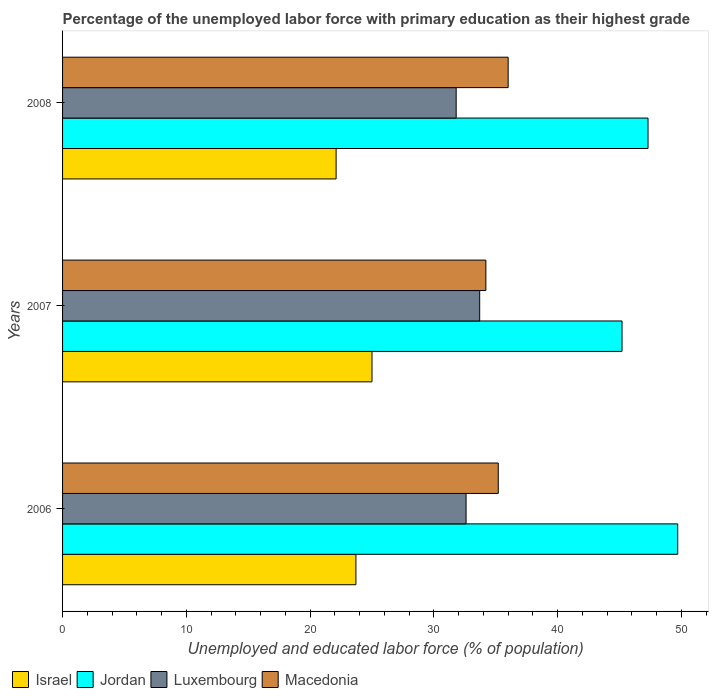How many different coloured bars are there?
Your response must be concise. 4. How many groups of bars are there?
Offer a very short reply. 3. Are the number of bars on each tick of the Y-axis equal?
Provide a short and direct response. Yes. How many bars are there on the 3rd tick from the top?
Provide a succinct answer. 4. How many bars are there on the 2nd tick from the bottom?
Offer a very short reply. 4. What is the label of the 2nd group of bars from the top?
Offer a very short reply. 2007. What is the percentage of the unemployed labor force with primary education in Israel in 2006?
Ensure brevity in your answer.  23.7. Across all years, what is the maximum percentage of the unemployed labor force with primary education in Luxembourg?
Your answer should be compact. 33.7. Across all years, what is the minimum percentage of the unemployed labor force with primary education in Jordan?
Your answer should be very brief. 45.2. In which year was the percentage of the unemployed labor force with primary education in Luxembourg minimum?
Make the answer very short. 2008. What is the total percentage of the unemployed labor force with primary education in Luxembourg in the graph?
Your answer should be compact. 98.1. What is the difference between the percentage of the unemployed labor force with primary education in Israel in 2006 and that in 2007?
Offer a very short reply. -1.3. What is the average percentage of the unemployed labor force with primary education in Luxembourg per year?
Ensure brevity in your answer.  32.7. In the year 2007, what is the difference between the percentage of the unemployed labor force with primary education in Israel and percentage of the unemployed labor force with primary education in Luxembourg?
Provide a succinct answer. -8.7. What is the ratio of the percentage of the unemployed labor force with primary education in Jordan in 2007 to that in 2008?
Your answer should be compact. 0.96. Is the percentage of the unemployed labor force with primary education in Israel in 2007 less than that in 2008?
Offer a terse response. No. What is the difference between the highest and the second highest percentage of the unemployed labor force with primary education in Luxembourg?
Give a very brief answer. 1.1. What is the difference between the highest and the lowest percentage of the unemployed labor force with primary education in Macedonia?
Your response must be concise. 1.8. Is the sum of the percentage of the unemployed labor force with primary education in Macedonia in 2006 and 2008 greater than the maximum percentage of the unemployed labor force with primary education in Israel across all years?
Make the answer very short. Yes. Is it the case that in every year, the sum of the percentage of the unemployed labor force with primary education in Israel and percentage of the unemployed labor force with primary education in Jordan is greater than the sum of percentage of the unemployed labor force with primary education in Macedonia and percentage of the unemployed labor force with primary education in Luxembourg?
Provide a short and direct response. Yes. What does the 4th bar from the bottom in 2006 represents?
Your answer should be compact. Macedonia. Is it the case that in every year, the sum of the percentage of the unemployed labor force with primary education in Luxembourg and percentage of the unemployed labor force with primary education in Macedonia is greater than the percentage of the unemployed labor force with primary education in Israel?
Make the answer very short. Yes. What is the difference between two consecutive major ticks on the X-axis?
Your answer should be compact. 10. Are the values on the major ticks of X-axis written in scientific E-notation?
Keep it short and to the point. No. Does the graph contain any zero values?
Provide a short and direct response. No. How many legend labels are there?
Offer a very short reply. 4. How are the legend labels stacked?
Provide a short and direct response. Horizontal. What is the title of the graph?
Make the answer very short. Percentage of the unemployed labor force with primary education as their highest grade. Does "Gambia, The" appear as one of the legend labels in the graph?
Keep it short and to the point. No. What is the label or title of the X-axis?
Offer a very short reply. Unemployed and educated labor force (% of population). What is the label or title of the Y-axis?
Make the answer very short. Years. What is the Unemployed and educated labor force (% of population) in Israel in 2006?
Make the answer very short. 23.7. What is the Unemployed and educated labor force (% of population) of Jordan in 2006?
Your response must be concise. 49.7. What is the Unemployed and educated labor force (% of population) of Luxembourg in 2006?
Offer a very short reply. 32.6. What is the Unemployed and educated labor force (% of population) in Macedonia in 2006?
Ensure brevity in your answer.  35.2. What is the Unemployed and educated labor force (% of population) of Jordan in 2007?
Make the answer very short. 45.2. What is the Unemployed and educated labor force (% of population) of Luxembourg in 2007?
Offer a very short reply. 33.7. What is the Unemployed and educated labor force (% of population) of Macedonia in 2007?
Keep it short and to the point. 34.2. What is the Unemployed and educated labor force (% of population) in Israel in 2008?
Your answer should be very brief. 22.1. What is the Unemployed and educated labor force (% of population) in Jordan in 2008?
Provide a succinct answer. 47.3. What is the Unemployed and educated labor force (% of population) in Luxembourg in 2008?
Your answer should be compact. 31.8. What is the Unemployed and educated labor force (% of population) in Macedonia in 2008?
Keep it short and to the point. 36. Across all years, what is the maximum Unemployed and educated labor force (% of population) of Israel?
Your answer should be very brief. 25. Across all years, what is the maximum Unemployed and educated labor force (% of population) of Jordan?
Offer a terse response. 49.7. Across all years, what is the maximum Unemployed and educated labor force (% of population) in Luxembourg?
Your response must be concise. 33.7. Across all years, what is the maximum Unemployed and educated labor force (% of population) in Macedonia?
Ensure brevity in your answer.  36. Across all years, what is the minimum Unemployed and educated labor force (% of population) in Israel?
Provide a short and direct response. 22.1. Across all years, what is the minimum Unemployed and educated labor force (% of population) of Jordan?
Give a very brief answer. 45.2. Across all years, what is the minimum Unemployed and educated labor force (% of population) in Luxembourg?
Provide a short and direct response. 31.8. Across all years, what is the minimum Unemployed and educated labor force (% of population) of Macedonia?
Your response must be concise. 34.2. What is the total Unemployed and educated labor force (% of population) in Israel in the graph?
Give a very brief answer. 70.8. What is the total Unemployed and educated labor force (% of population) in Jordan in the graph?
Your answer should be compact. 142.2. What is the total Unemployed and educated labor force (% of population) in Luxembourg in the graph?
Provide a succinct answer. 98.1. What is the total Unemployed and educated labor force (% of population) in Macedonia in the graph?
Your response must be concise. 105.4. What is the difference between the Unemployed and educated labor force (% of population) in Macedonia in 2006 and that in 2007?
Make the answer very short. 1. What is the difference between the Unemployed and educated labor force (% of population) of Jordan in 2006 and that in 2008?
Make the answer very short. 2.4. What is the difference between the Unemployed and educated labor force (% of population) in Luxembourg in 2006 and that in 2008?
Your answer should be very brief. 0.8. What is the difference between the Unemployed and educated labor force (% of population) in Israel in 2007 and that in 2008?
Your answer should be very brief. 2.9. What is the difference between the Unemployed and educated labor force (% of population) of Jordan in 2007 and that in 2008?
Your answer should be very brief. -2.1. What is the difference between the Unemployed and educated labor force (% of population) in Israel in 2006 and the Unemployed and educated labor force (% of population) in Jordan in 2007?
Your response must be concise. -21.5. What is the difference between the Unemployed and educated labor force (% of population) in Israel in 2006 and the Unemployed and educated labor force (% of population) in Luxembourg in 2007?
Provide a short and direct response. -10. What is the difference between the Unemployed and educated labor force (% of population) in Israel in 2006 and the Unemployed and educated labor force (% of population) in Macedonia in 2007?
Make the answer very short. -10.5. What is the difference between the Unemployed and educated labor force (% of population) in Jordan in 2006 and the Unemployed and educated labor force (% of population) in Luxembourg in 2007?
Make the answer very short. 16. What is the difference between the Unemployed and educated labor force (% of population) of Israel in 2006 and the Unemployed and educated labor force (% of population) of Jordan in 2008?
Offer a very short reply. -23.6. What is the difference between the Unemployed and educated labor force (% of population) of Jordan in 2006 and the Unemployed and educated labor force (% of population) of Macedonia in 2008?
Keep it short and to the point. 13.7. What is the difference between the Unemployed and educated labor force (% of population) in Israel in 2007 and the Unemployed and educated labor force (% of population) in Jordan in 2008?
Make the answer very short. -22.3. What is the difference between the Unemployed and educated labor force (% of population) in Israel in 2007 and the Unemployed and educated labor force (% of population) in Luxembourg in 2008?
Your answer should be compact. -6.8. What is the difference between the Unemployed and educated labor force (% of population) in Jordan in 2007 and the Unemployed and educated labor force (% of population) in Luxembourg in 2008?
Your answer should be compact. 13.4. What is the difference between the Unemployed and educated labor force (% of population) in Luxembourg in 2007 and the Unemployed and educated labor force (% of population) in Macedonia in 2008?
Your answer should be compact. -2.3. What is the average Unemployed and educated labor force (% of population) of Israel per year?
Your answer should be compact. 23.6. What is the average Unemployed and educated labor force (% of population) of Jordan per year?
Your answer should be compact. 47.4. What is the average Unemployed and educated labor force (% of population) of Luxembourg per year?
Make the answer very short. 32.7. What is the average Unemployed and educated labor force (% of population) of Macedonia per year?
Your answer should be compact. 35.13. In the year 2006, what is the difference between the Unemployed and educated labor force (% of population) in Jordan and Unemployed and educated labor force (% of population) in Luxembourg?
Your answer should be compact. 17.1. In the year 2006, what is the difference between the Unemployed and educated labor force (% of population) in Luxembourg and Unemployed and educated labor force (% of population) in Macedonia?
Provide a short and direct response. -2.6. In the year 2007, what is the difference between the Unemployed and educated labor force (% of population) of Israel and Unemployed and educated labor force (% of population) of Jordan?
Your answer should be compact. -20.2. In the year 2007, what is the difference between the Unemployed and educated labor force (% of population) in Jordan and Unemployed and educated labor force (% of population) in Luxembourg?
Your answer should be compact. 11.5. In the year 2007, what is the difference between the Unemployed and educated labor force (% of population) of Jordan and Unemployed and educated labor force (% of population) of Macedonia?
Your response must be concise. 11. In the year 2008, what is the difference between the Unemployed and educated labor force (% of population) of Israel and Unemployed and educated labor force (% of population) of Jordan?
Give a very brief answer. -25.2. In the year 2008, what is the difference between the Unemployed and educated labor force (% of population) of Israel and Unemployed and educated labor force (% of population) of Macedonia?
Keep it short and to the point. -13.9. In the year 2008, what is the difference between the Unemployed and educated labor force (% of population) in Jordan and Unemployed and educated labor force (% of population) in Luxembourg?
Offer a terse response. 15.5. In the year 2008, what is the difference between the Unemployed and educated labor force (% of population) of Jordan and Unemployed and educated labor force (% of population) of Macedonia?
Your response must be concise. 11.3. In the year 2008, what is the difference between the Unemployed and educated labor force (% of population) in Luxembourg and Unemployed and educated labor force (% of population) in Macedonia?
Your answer should be compact. -4.2. What is the ratio of the Unemployed and educated labor force (% of population) in Israel in 2006 to that in 2007?
Ensure brevity in your answer.  0.95. What is the ratio of the Unemployed and educated labor force (% of population) in Jordan in 2006 to that in 2007?
Your response must be concise. 1.1. What is the ratio of the Unemployed and educated labor force (% of population) in Luxembourg in 2006 to that in 2007?
Offer a very short reply. 0.97. What is the ratio of the Unemployed and educated labor force (% of population) in Macedonia in 2006 to that in 2007?
Your response must be concise. 1.03. What is the ratio of the Unemployed and educated labor force (% of population) in Israel in 2006 to that in 2008?
Make the answer very short. 1.07. What is the ratio of the Unemployed and educated labor force (% of population) in Jordan in 2006 to that in 2008?
Your response must be concise. 1.05. What is the ratio of the Unemployed and educated labor force (% of population) in Luxembourg in 2006 to that in 2008?
Give a very brief answer. 1.03. What is the ratio of the Unemployed and educated labor force (% of population) of Macedonia in 2006 to that in 2008?
Ensure brevity in your answer.  0.98. What is the ratio of the Unemployed and educated labor force (% of population) in Israel in 2007 to that in 2008?
Offer a terse response. 1.13. What is the ratio of the Unemployed and educated labor force (% of population) of Jordan in 2007 to that in 2008?
Offer a very short reply. 0.96. What is the ratio of the Unemployed and educated labor force (% of population) of Luxembourg in 2007 to that in 2008?
Your answer should be compact. 1.06. What is the difference between the highest and the second highest Unemployed and educated labor force (% of population) in Israel?
Provide a succinct answer. 1.3. What is the difference between the highest and the second highest Unemployed and educated labor force (% of population) of Macedonia?
Ensure brevity in your answer.  0.8. What is the difference between the highest and the lowest Unemployed and educated labor force (% of population) in Israel?
Ensure brevity in your answer.  2.9. What is the difference between the highest and the lowest Unemployed and educated labor force (% of population) in Macedonia?
Ensure brevity in your answer.  1.8. 